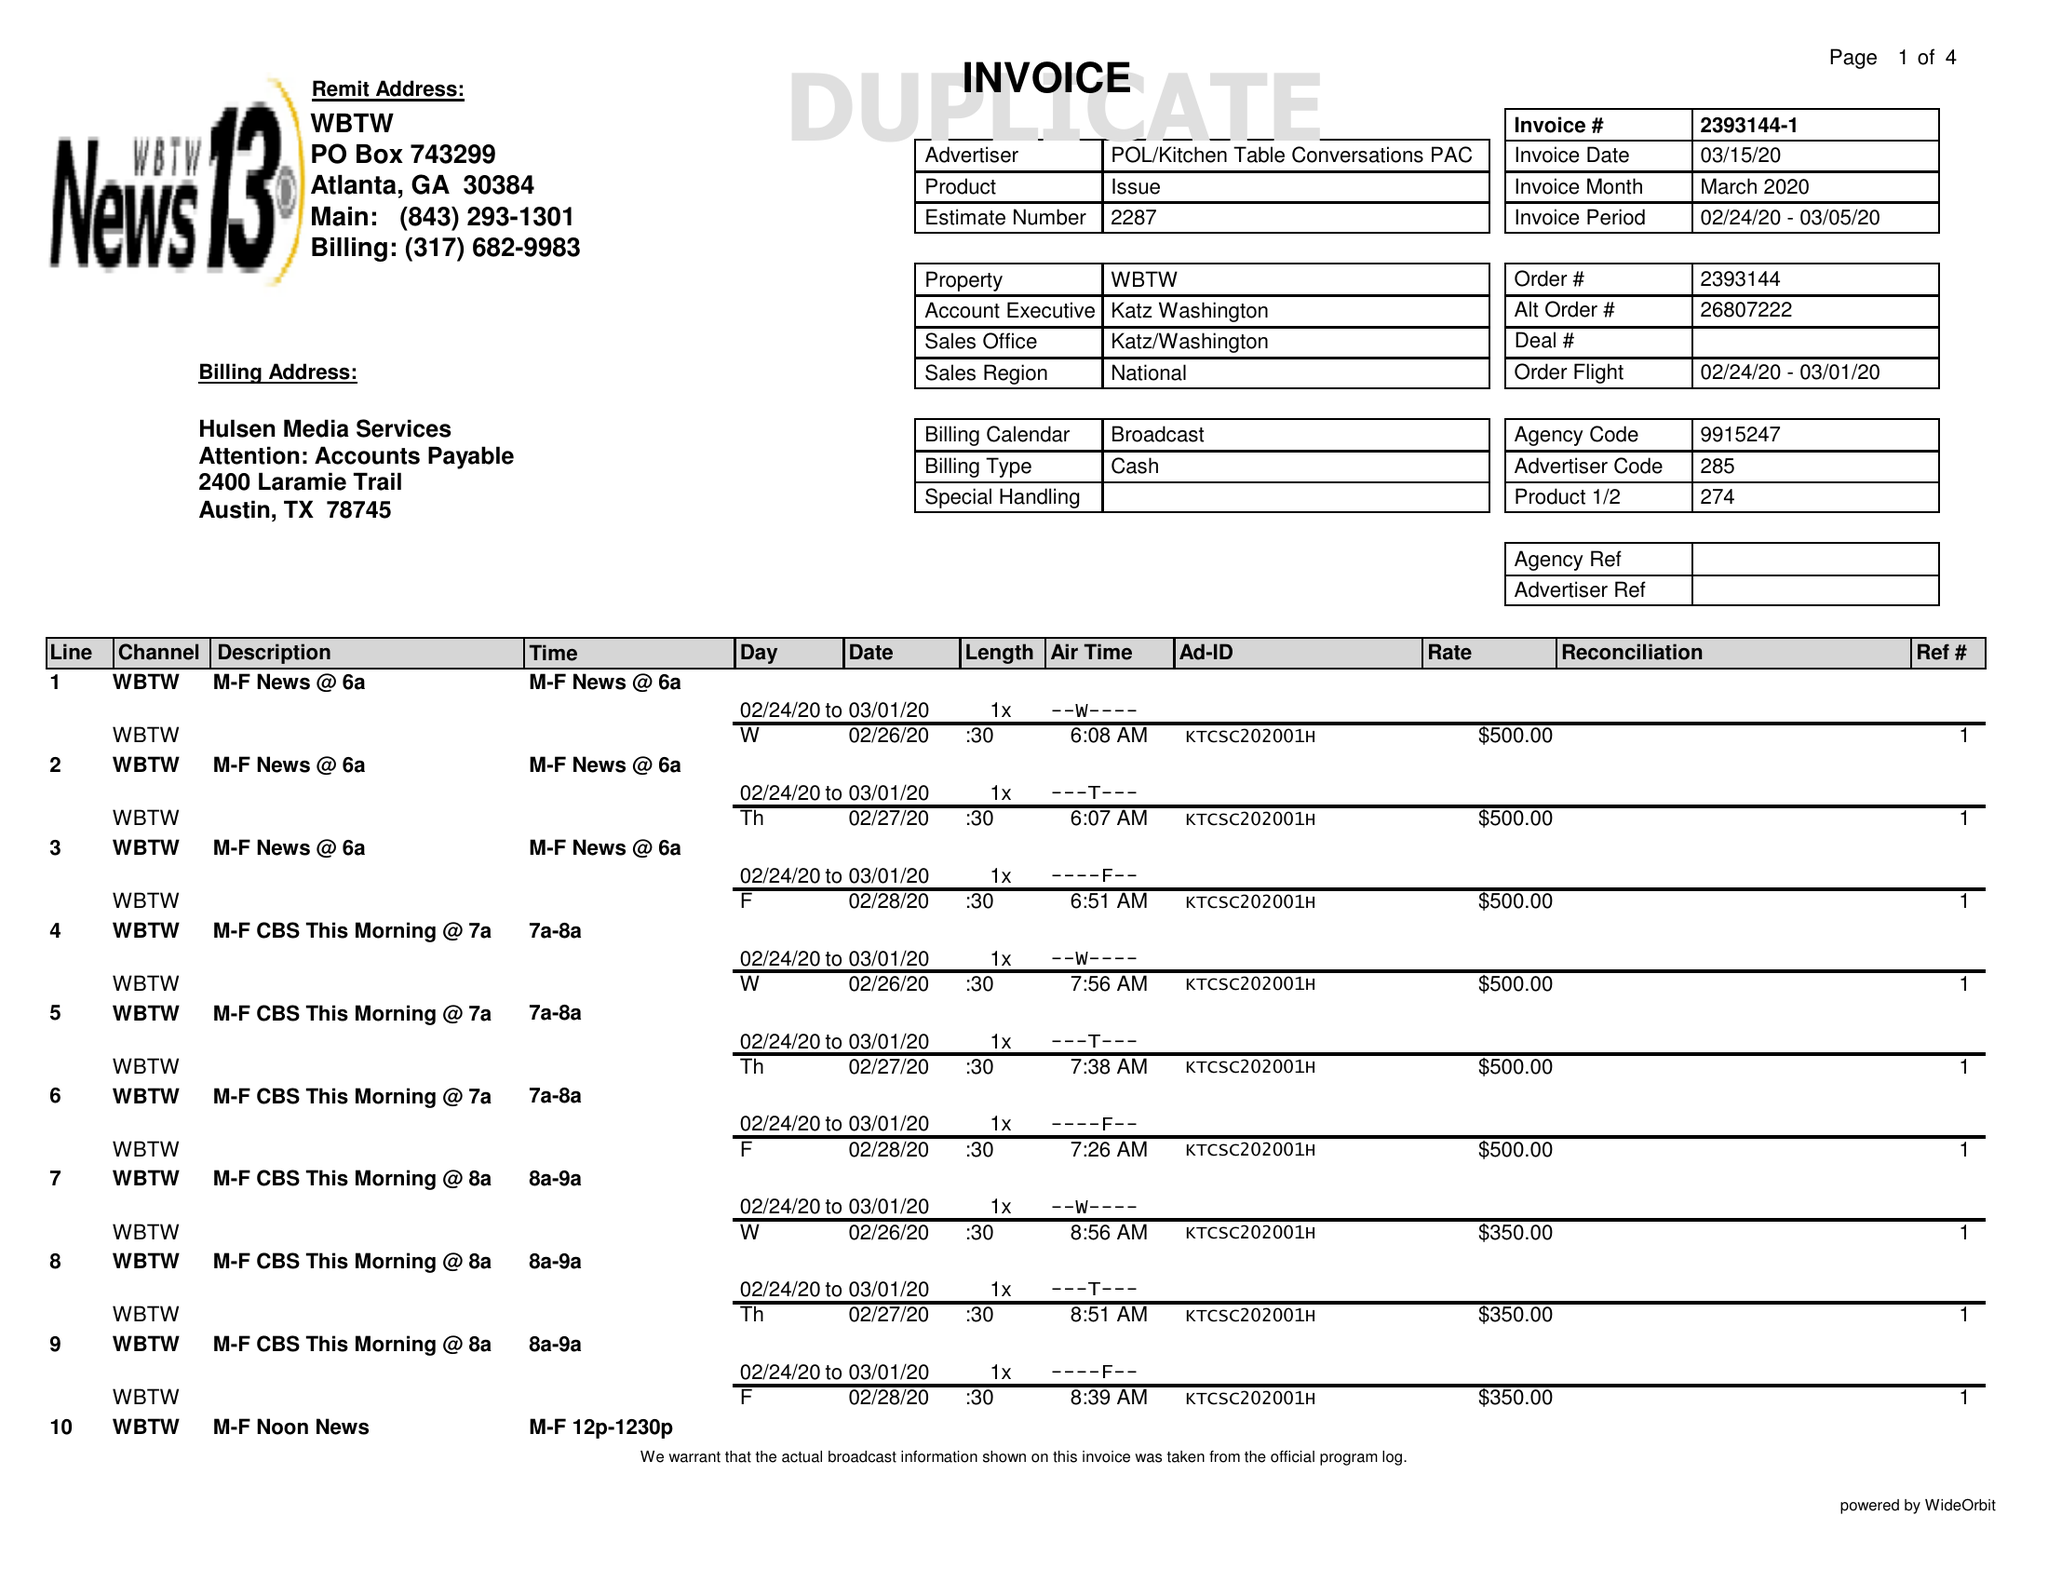What is the value for the flight_from?
Answer the question using a single word or phrase. 02/24/20 